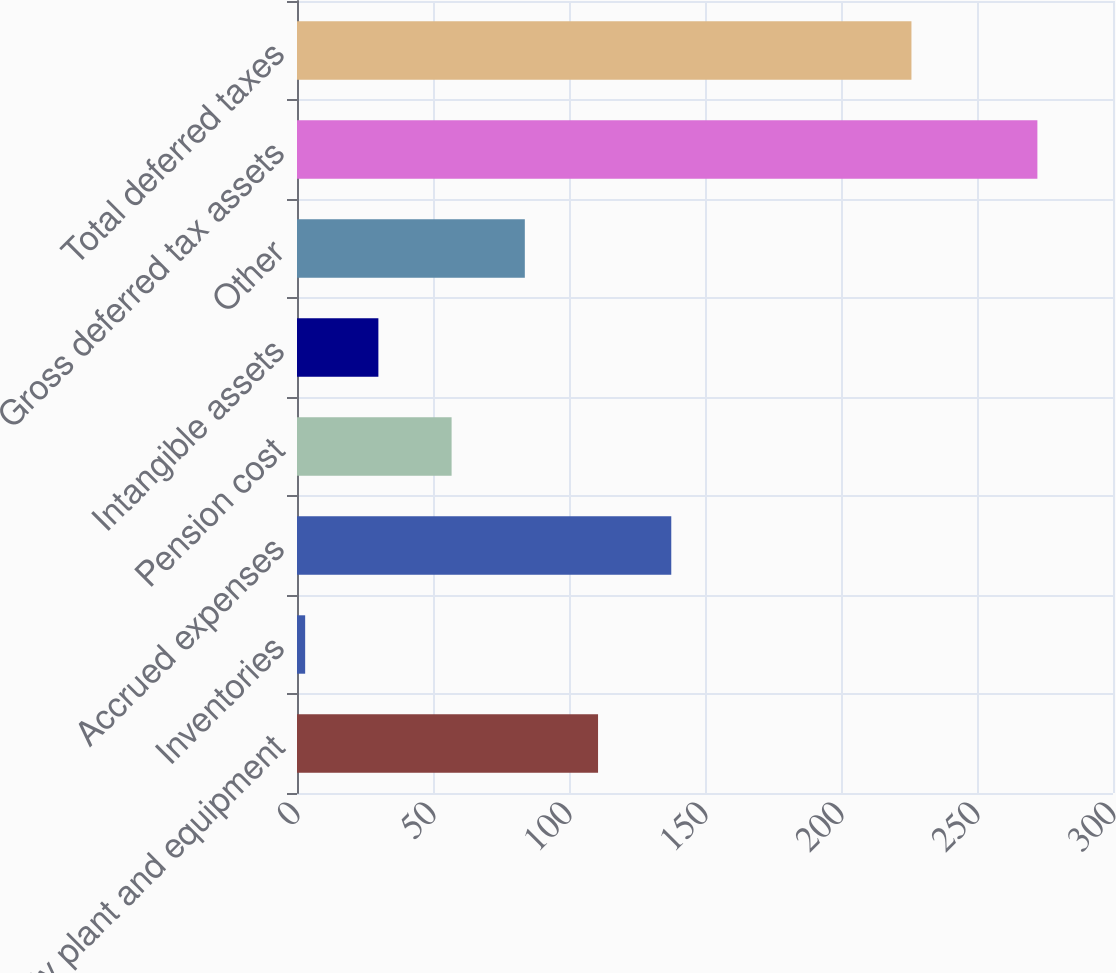<chart> <loc_0><loc_0><loc_500><loc_500><bar_chart><fcel>Property plant and equipment<fcel>Inventories<fcel>Accrued expenses<fcel>Pension cost<fcel>Intangible assets<fcel>Other<fcel>Gross deferred tax assets<fcel>Total deferred taxes<nl><fcel>110.68<fcel>3<fcel>137.6<fcel>56.84<fcel>29.92<fcel>83.76<fcel>272.2<fcel>225.9<nl></chart> 